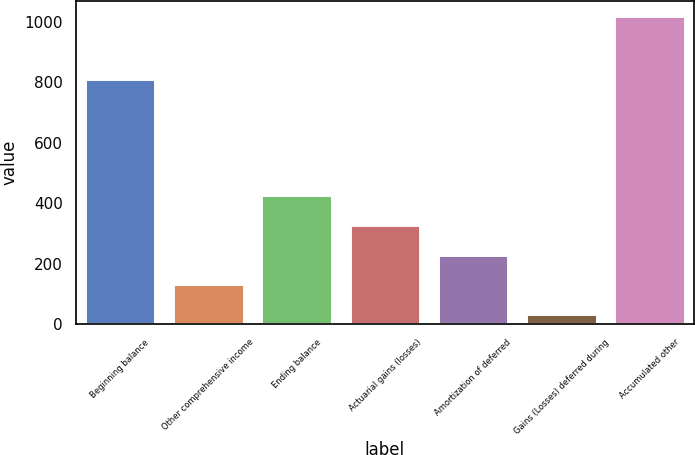Convert chart to OTSL. <chart><loc_0><loc_0><loc_500><loc_500><bar_chart><fcel>Beginning balance<fcel>Other comprehensive income<fcel>Ending balance<fcel>Actuarial gains (losses)<fcel>Amortization of deferred<fcel>Gains (Losses) deferred during<fcel>Accumulated other<nl><fcel>812<fcel>132.5<fcel>428<fcel>329.5<fcel>231<fcel>34<fcel>1019<nl></chart> 